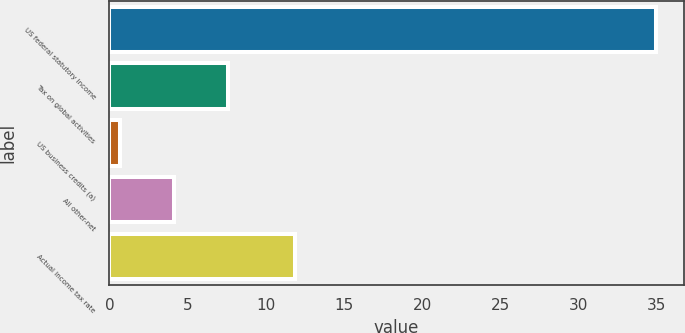Convert chart to OTSL. <chart><loc_0><loc_0><loc_500><loc_500><bar_chart><fcel>US federal statutory income<fcel>Tax on global activities<fcel>US business credits (a)<fcel>All other-net<fcel>Actual income tax rate<nl><fcel>35<fcel>7.56<fcel>0.7<fcel>4.13<fcel>11.9<nl></chart> 